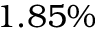<formula> <loc_0><loc_0><loc_500><loc_500>1 . 8 5 \%</formula> 